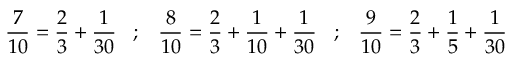Convert formula to latex. <formula><loc_0><loc_0><loc_500><loc_500>{ \frac { 7 } { 1 0 } } = { \frac { 2 } { 3 } } + { \frac { 1 } { 3 0 } } \, ; \, { \frac { 8 } { 1 0 } } = { \frac { 2 } { 3 } } + { \frac { 1 } { 1 0 } } + { \frac { 1 } { 3 0 } } \, ; \, { \frac { 9 } { 1 0 } } = { \frac { 2 } { 3 } } + { \frac { 1 } { 5 } } + { \frac { 1 } { 3 0 } }</formula> 